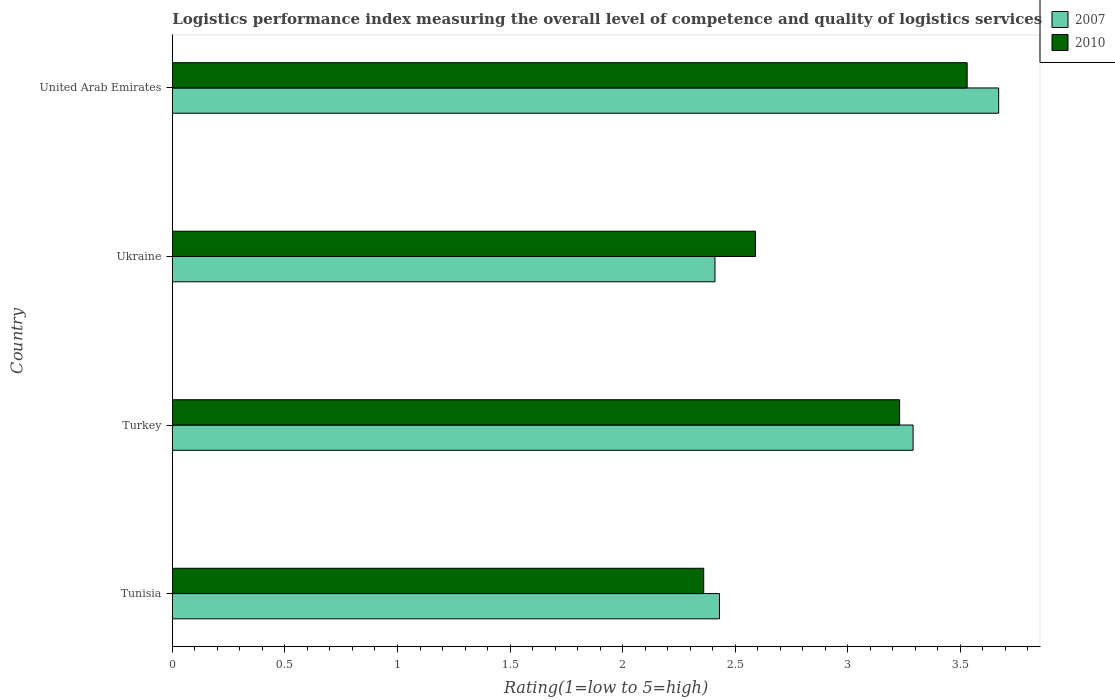Are the number of bars on each tick of the Y-axis equal?
Your answer should be compact. Yes. What is the label of the 2nd group of bars from the top?
Give a very brief answer. Ukraine. In how many cases, is the number of bars for a given country not equal to the number of legend labels?
Make the answer very short. 0. What is the Logistic performance index in 2010 in Turkey?
Your answer should be very brief. 3.23. Across all countries, what is the maximum Logistic performance index in 2007?
Provide a succinct answer. 3.67. Across all countries, what is the minimum Logistic performance index in 2010?
Your answer should be compact. 2.36. In which country was the Logistic performance index in 2007 maximum?
Give a very brief answer. United Arab Emirates. In which country was the Logistic performance index in 2007 minimum?
Offer a very short reply. Ukraine. What is the difference between the Logistic performance index in 2007 in Turkey and that in Ukraine?
Your answer should be very brief. 0.88. What is the difference between the Logistic performance index in 2010 in Ukraine and the Logistic performance index in 2007 in Tunisia?
Keep it short and to the point. 0.16. What is the average Logistic performance index in 2007 per country?
Keep it short and to the point. 2.95. What is the difference between the Logistic performance index in 2007 and Logistic performance index in 2010 in Tunisia?
Offer a very short reply. 0.07. What is the ratio of the Logistic performance index in 2010 in Tunisia to that in Ukraine?
Keep it short and to the point. 0.91. Is the Logistic performance index in 2007 in Tunisia less than that in United Arab Emirates?
Ensure brevity in your answer.  Yes. Is the difference between the Logistic performance index in 2007 in Tunisia and Ukraine greater than the difference between the Logistic performance index in 2010 in Tunisia and Ukraine?
Your answer should be compact. Yes. What is the difference between the highest and the second highest Logistic performance index in 2007?
Provide a succinct answer. 0.38. What is the difference between the highest and the lowest Logistic performance index in 2010?
Your response must be concise. 1.17. What does the 1st bar from the bottom in Turkey represents?
Provide a short and direct response. 2007. Are all the bars in the graph horizontal?
Keep it short and to the point. Yes. What is the difference between two consecutive major ticks on the X-axis?
Offer a very short reply. 0.5. Does the graph contain any zero values?
Offer a very short reply. No. Does the graph contain grids?
Offer a terse response. No. How many legend labels are there?
Ensure brevity in your answer.  2. How are the legend labels stacked?
Make the answer very short. Vertical. What is the title of the graph?
Provide a short and direct response. Logistics performance index measuring the overall level of competence and quality of logistics services. Does "1986" appear as one of the legend labels in the graph?
Provide a succinct answer. No. What is the label or title of the X-axis?
Give a very brief answer. Rating(1=low to 5=high). What is the Rating(1=low to 5=high) in 2007 in Tunisia?
Make the answer very short. 2.43. What is the Rating(1=low to 5=high) in 2010 in Tunisia?
Your response must be concise. 2.36. What is the Rating(1=low to 5=high) of 2007 in Turkey?
Make the answer very short. 3.29. What is the Rating(1=low to 5=high) in 2010 in Turkey?
Provide a short and direct response. 3.23. What is the Rating(1=low to 5=high) of 2007 in Ukraine?
Your answer should be very brief. 2.41. What is the Rating(1=low to 5=high) of 2010 in Ukraine?
Your answer should be compact. 2.59. What is the Rating(1=low to 5=high) of 2007 in United Arab Emirates?
Offer a terse response. 3.67. What is the Rating(1=low to 5=high) in 2010 in United Arab Emirates?
Your answer should be very brief. 3.53. Across all countries, what is the maximum Rating(1=low to 5=high) of 2007?
Provide a succinct answer. 3.67. Across all countries, what is the maximum Rating(1=low to 5=high) in 2010?
Keep it short and to the point. 3.53. Across all countries, what is the minimum Rating(1=low to 5=high) of 2007?
Ensure brevity in your answer.  2.41. Across all countries, what is the minimum Rating(1=low to 5=high) of 2010?
Provide a short and direct response. 2.36. What is the total Rating(1=low to 5=high) of 2010 in the graph?
Ensure brevity in your answer.  11.71. What is the difference between the Rating(1=low to 5=high) in 2007 in Tunisia and that in Turkey?
Your response must be concise. -0.86. What is the difference between the Rating(1=low to 5=high) of 2010 in Tunisia and that in Turkey?
Provide a succinct answer. -0.87. What is the difference between the Rating(1=low to 5=high) in 2010 in Tunisia and that in Ukraine?
Your answer should be very brief. -0.23. What is the difference between the Rating(1=low to 5=high) in 2007 in Tunisia and that in United Arab Emirates?
Your answer should be compact. -1.24. What is the difference between the Rating(1=low to 5=high) in 2010 in Tunisia and that in United Arab Emirates?
Your answer should be very brief. -1.17. What is the difference between the Rating(1=low to 5=high) in 2010 in Turkey and that in Ukraine?
Keep it short and to the point. 0.64. What is the difference between the Rating(1=low to 5=high) of 2007 in Turkey and that in United Arab Emirates?
Keep it short and to the point. -0.38. What is the difference between the Rating(1=low to 5=high) in 2010 in Turkey and that in United Arab Emirates?
Provide a succinct answer. -0.3. What is the difference between the Rating(1=low to 5=high) in 2007 in Ukraine and that in United Arab Emirates?
Your response must be concise. -1.26. What is the difference between the Rating(1=low to 5=high) in 2010 in Ukraine and that in United Arab Emirates?
Your answer should be very brief. -0.94. What is the difference between the Rating(1=low to 5=high) of 2007 in Tunisia and the Rating(1=low to 5=high) of 2010 in Turkey?
Your answer should be very brief. -0.8. What is the difference between the Rating(1=low to 5=high) of 2007 in Tunisia and the Rating(1=low to 5=high) of 2010 in Ukraine?
Keep it short and to the point. -0.16. What is the difference between the Rating(1=low to 5=high) in 2007 in Tunisia and the Rating(1=low to 5=high) in 2010 in United Arab Emirates?
Provide a succinct answer. -1.1. What is the difference between the Rating(1=low to 5=high) of 2007 in Turkey and the Rating(1=low to 5=high) of 2010 in Ukraine?
Keep it short and to the point. 0.7. What is the difference between the Rating(1=low to 5=high) in 2007 in Turkey and the Rating(1=low to 5=high) in 2010 in United Arab Emirates?
Provide a succinct answer. -0.24. What is the difference between the Rating(1=low to 5=high) in 2007 in Ukraine and the Rating(1=low to 5=high) in 2010 in United Arab Emirates?
Offer a terse response. -1.12. What is the average Rating(1=low to 5=high) in 2007 per country?
Give a very brief answer. 2.95. What is the average Rating(1=low to 5=high) of 2010 per country?
Keep it short and to the point. 2.93. What is the difference between the Rating(1=low to 5=high) in 2007 and Rating(1=low to 5=high) in 2010 in Tunisia?
Provide a short and direct response. 0.07. What is the difference between the Rating(1=low to 5=high) of 2007 and Rating(1=low to 5=high) of 2010 in Turkey?
Provide a succinct answer. 0.06. What is the difference between the Rating(1=low to 5=high) of 2007 and Rating(1=low to 5=high) of 2010 in Ukraine?
Give a very brief answer. -0.18. What is the difference between the Rating(1=low to 5=high) in 2007 and Rating(1=low to 5=high) in 2010 in United Arab Emirates?
Your response must be concise. 0.14. What is the ratio of the Rating(1=low to 5=high) in 2007 in Tunisia to that in Turkey?
Keep it short and to the point. 0.74. What is the ratio of the Rating(1=low to 5=high) in 2010 in Tunisia to that in Turkey?
Keep it short and to the point. 0.73. What is the ratio of the Rating(1=low to 5=high) in 2007 in Tunisia to that in Ukraine?
Give a very brief answer. 1.01. What is the ratio of the Rating(1=low to 5=high) of 2010 in Tunisia to that in Ukraine?
Your response must be concise. 0.91. What is the ratio of the Rating(1=low to 5=high) of 2007 in Tunisia to that in United Arab Emirates?
Make the answer very short. 0.66. What is the ratio of the Rating(1=low to 5=high) of 2010 in Tunisia to that in United Arab Emirates?
Offer a terse response. 0.67. What is the ratio of the Rating(1=low to 5=high) of 2007 in Turkey to that in Ukraine?
Your answer should be very brief. 1.37. What is the ratio of the Rating(1=low to 5=high) in 2010 in Turkey to that in Ukraine?
Your response must be concise. 1.25. What is the ratio of the Rating(1=low to 5=high) of 2007 in Turkey to that in United Arab Emirates?
Make the answer very short. 0.9. What is the ratio of the Rating(1=low to 5=high) in 2010 in Turkey to that in United Arab Emirates?
Your response must be concise. 0.92. What is the ratio of the Rating(1=low to 5=high) in 2007 in Ukraine to that in United Arab Emirates?
Keep it short and to the point. 0.66. What is the ratio of the Rating(1=low to 5=high) of 2010 in Ukraine to that in United Arab Emirates?
Keep it short and to the point. 0.73. What is the difference between the highest and the second highest Rating(1=low to 5=high) of 2007?
Ensure brevity in your answer.  0.38. What is the difference between the highest and the second highest Rating(1=low to 5=high) in 2010?
Make the answer very short. 0.3. What is the difference between the highest and the lowest Rating(1=low to 5=high) of 2007?
Keep it short and to the point. 1.26. What is the difference between the highest and the lowest Rating(1=low to 5=high) of 2010?
Make the answer very short. 1.17. 